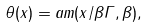<formula> <loc_0><loc_0><loc_500><loc_500>\theta ( x ) = a m ( x / \beta \Gamma , \beta ) ,</formula> 